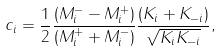<formula> <loc_0><loc_0><loc_500><loc_500>c _ { i } = \frac { 1 } { 2 } \frac { \left ( M ^ { - } _ { i } - M ^ { + } _ { i } \right ) } { \left ( M ^ { + } _ { i } + M ^ { - } _ { i } \right ) } \frac { \left ( K _ { i } + K _ { - i } \right ) } { \sqrt { K _ { i } K _ { - i } } } ,</formula> 